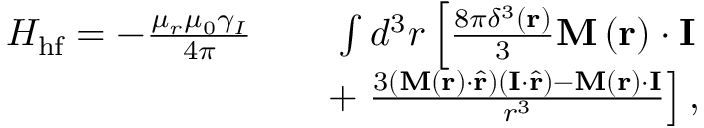Convert formula to latex. <formula><loc_0><loc_0><loc_500><loc_500>\begin{array} { r l r } { H _ { h f } = - \frac { \mu _ { r } \mu _ { 0 } \gamma _ { I } } { 4 \pi } } & { \int d ^ { 3 } r \left [ \frac { 8 \pi \delta ^ { 3 } \left ( r \right ) } { 3 } M \left ( r \right ) \cdot I } \\ & { + \frac { 3 \left ( M \left ( r \right ) \cdot \hat { r } \right ) \left ( I \cdot \hat { r } \right ) - M \left ( r \right ) \cdot I } { r ^ { 3 } } \right ] , } \end{array}</formula> 